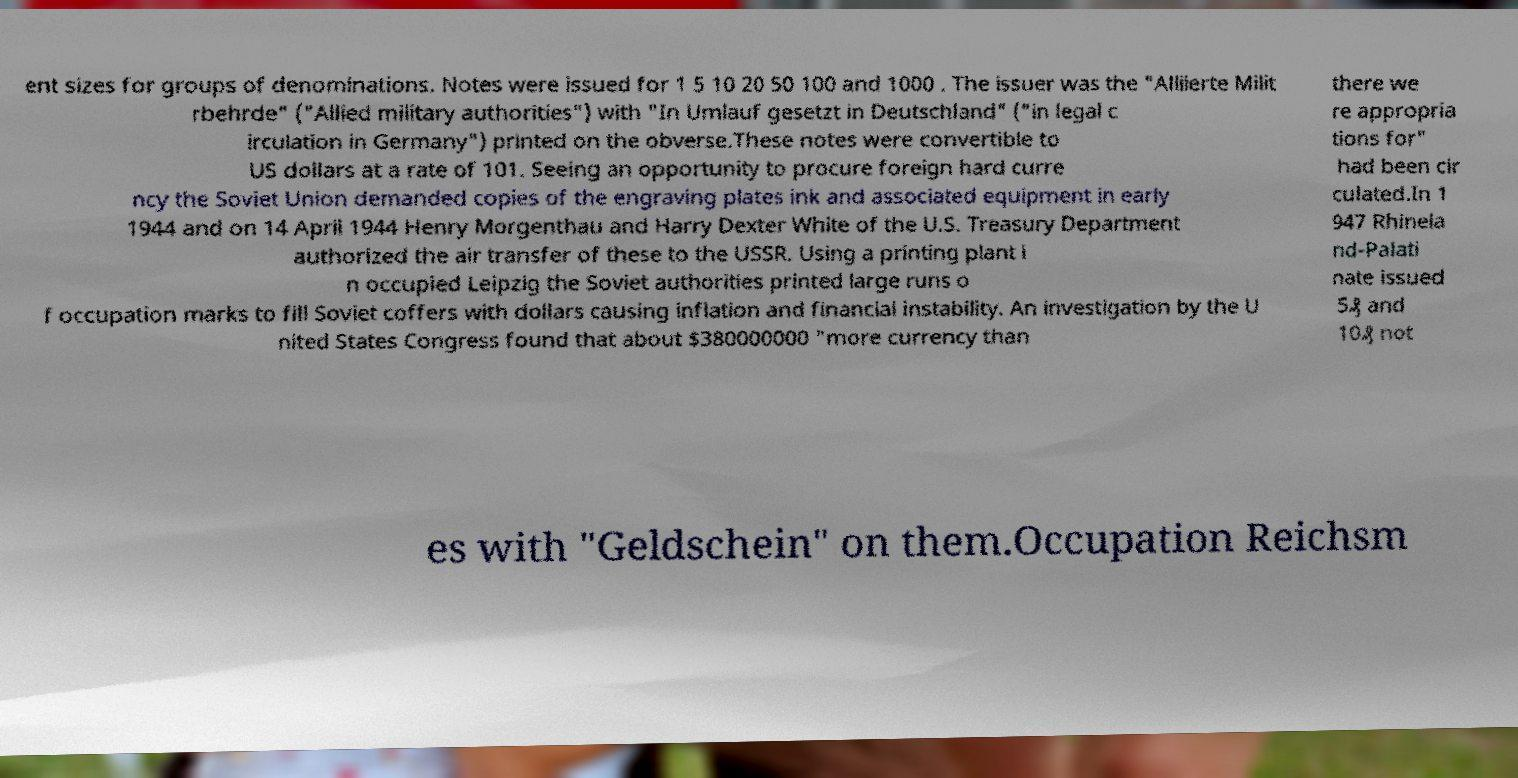I need the written content from this picture converted into text. Can you do that? ent sizes for groups of denominations. Notes were issued for 1 5 10 20 50 100 and 1000 . The issuer was the "Alliierte Milit rbehrde" ("Allied military authorities") with "In Umlauf gesetzt in Deutschland" ("in legal c irculation in Germany") printed on the obverse.These notes were convertible to US dollars at a rate of 101. Seeing an opportunity to procure foreign hard curre ncy the Soviet Union demanded copies of the engraving plates ink and associated equipment in early 1944 and on 14 April 1944 Henry Morgenthau and Harry Dexter White of the U.S. Treasury Department authorized the air transfer of these to the USSR. Using a printing plant i n occupied Leipzig the Soviet authorities printed large runs o f occupation marks to fill Soviet coffers with dollars causing inflation and financial instability. An investigation by the U nited States Congress found that about $380000000 "more currency than there we re appropria tions for" had been cir culated.In 1 947 Rhinela nd-Palati nate issued 5₰ and 10₰ not es with "Geldschein" on them.Occupation Reichsm 